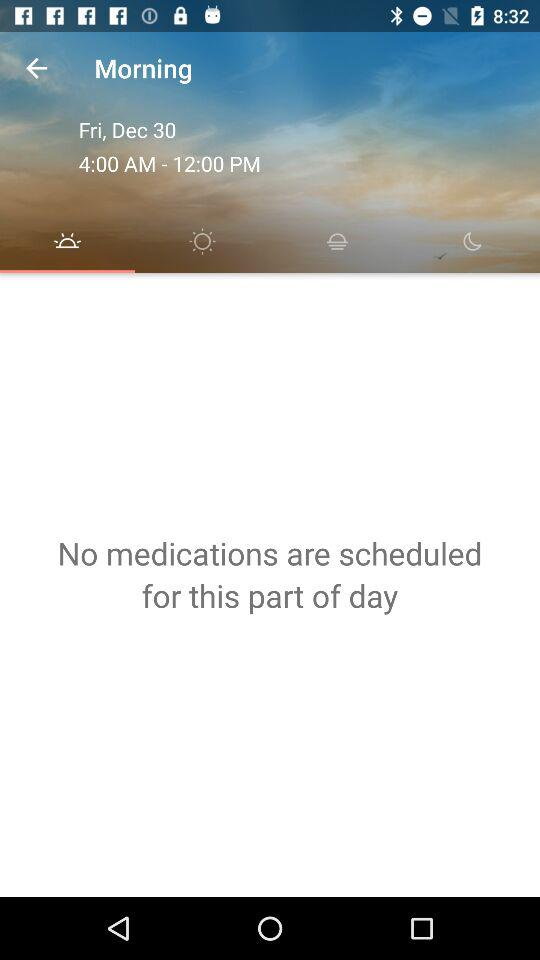What is the mentioned day? The mentioned day is Friday. 